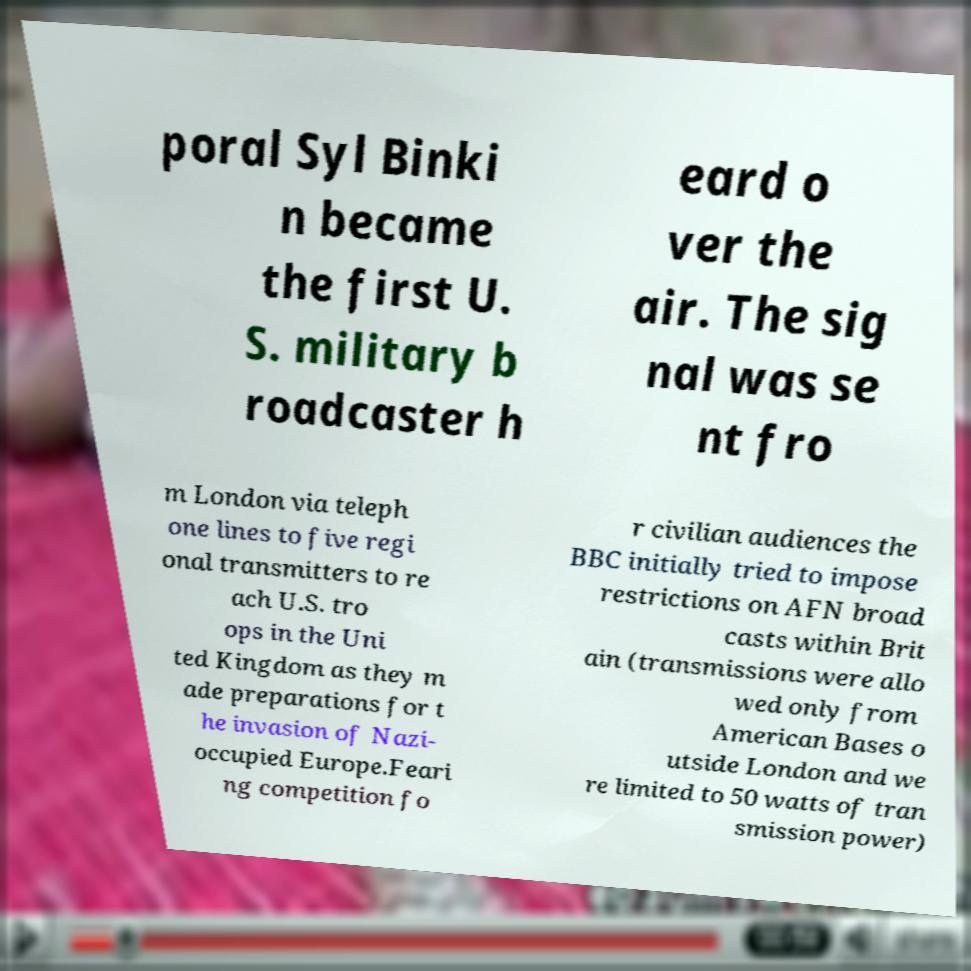Could you assist in decoding the text presented in this image and type it out clearly? poral Syl Binki n became the first U. S. military b roadcaster h eard o ver the air. The sig nal was se nt fro m London via teleph one lines to five regi onal transmitters to re ach U.S. tro ops in the Uni ted Kingdom as they m ade preparations for t he invasion of Nazi- occupied Europe.Feari ng competition fo r civilian audiences the BBC initially tried to impose restrictions on AFN broad casts within Brit ain (transmissions were allo wed only from American Bases o utside London and we re limited to 50 watts of tran smission power) 